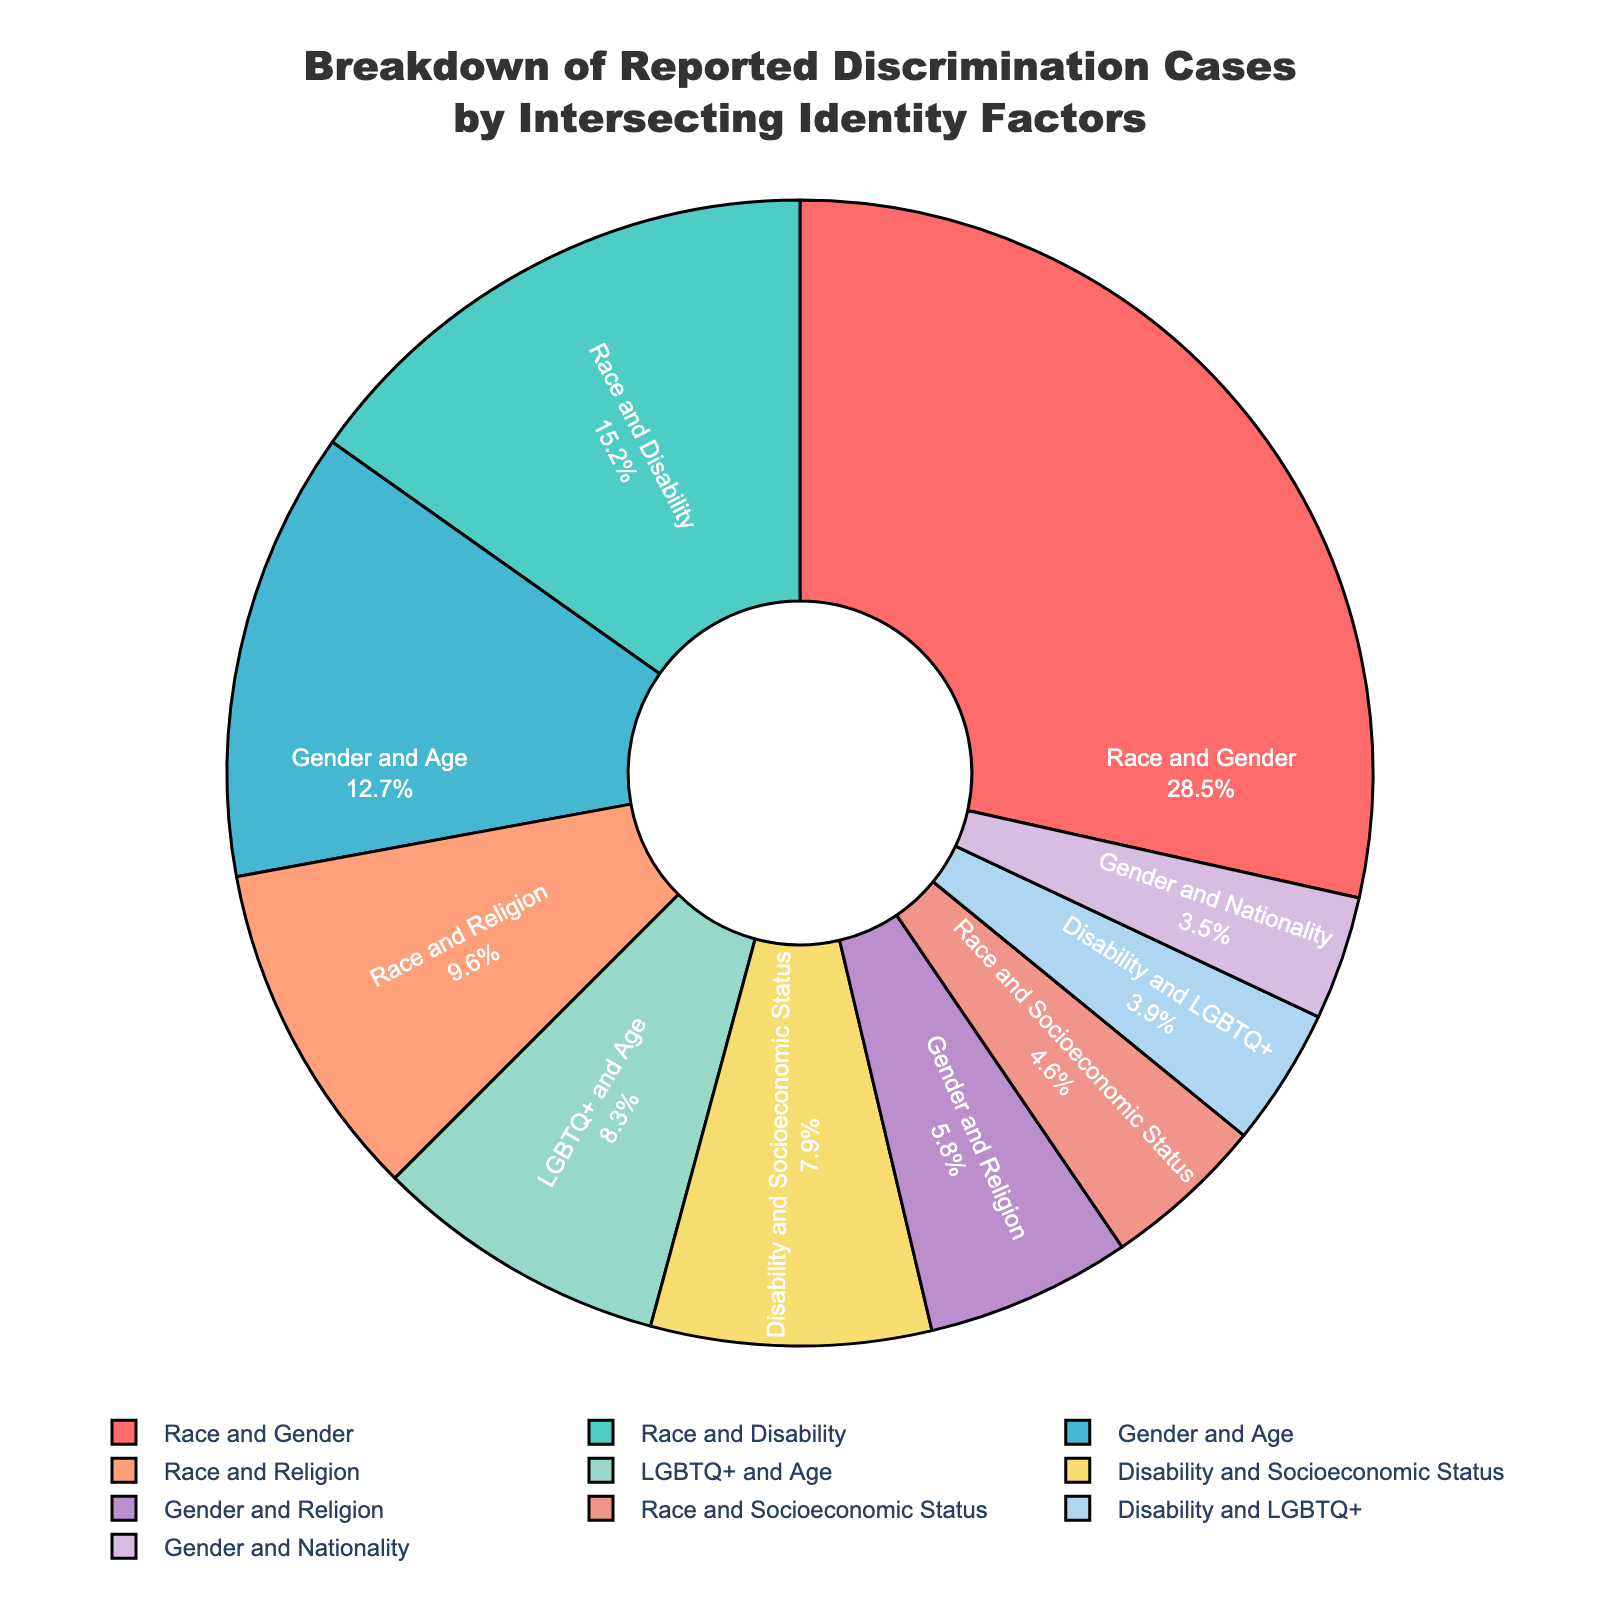What is the largest category of reported discrimination cases? The category "Race and Gender" has the largest percentage of reported discrimination cases at 28.5%.
Answer: Race and Gender What is the total percentage of discrimination cases that involve race? Adding the percentages for categories involving race: Race and Gender (28.5), Race and Disability (15.2), Race and Religion (9.6), and Race and Socioeconomic Status (4.6), the total is 28.5 + 15.2 + 9.6 + 4.6 = 57.9%.
Answer: 57.9% Which has more reported discrimination cases: Disability and LGBTQ+ or Gender and Nationality? Comparing the percentages, Disability and LGBTQ+ has 3.9% while Gender and Nationality has 3.5%. Therefore, Disability and LGBTQ+ has more cases.
Answer: Disability and LGBTQ+ How does the percentage of reported cases involving Disability and Socioeconomic Status compare to that involving Disability and LGBTQ+? The percentage for Disability and Socioeconomic Status is 7.9%, while for Disability and LGBTQ+ it is 3.9%. Hence, cases involving Disability and Socioeconomic Status are 4% higher.
Answer: 4% higher What is the combined percentage of reported discrimination cases involving Gender? Adding the percentages for categories involving gender: Race and Gender (28.5), Gender and Age (12.7), Gender and Religion (5.8), and Gender and Nationality (3.5), the total is 28.5 + 12.7 + 5.8 + 3.5 = 50.5%.
Answer: 50.5% Which categories have less than 5% of reported discrimination cases? The categories Race and Socioeconomic Status (4.6%), Disability and LGBTQ+ (3.9%), and Gender and Nationality (3.5%) each have less than 5% of reported cases.
Answer: Race and Socioeconomic Status, Disability and LGBTQ+, Gender and Nationality What is the median percentage of reported discrimination cases among all categories? The percentages are: 28.5, 15.2, 12.7, 9.6, 8.3, 7.9, 5.8, 4.6, 3.9, 3.5. Arranging them in ascending order: 3.5, 3.9, 4.6, 5.8, 7.9, 8.3, 9.6, 12.7, 15.2, 28.5. The median is the average of the 5th and 6th values: (7.9 + 8.3) / 2 = 8.1.
Answer: 8.1 What is the difference between the highest and lowest percentages of reported discrimination cases? The highest percentage is Race and Gender at 28.5%, and the lowest is Gender and Nationality at 3.5%. The difference is 28.5 - 3.5 = 25%.
Answer: 25% What color represents the category with the second highest percentage of reported discrimination cases? The second highest percentage is Race and Disability at 15.2%, represented by the color blue.
Answer: Blue How many categories have a percentage of reported discrimination cases greater than 10%? The categories are Race and Gender (28.5%), Race and Disability (15.2%), and Gender and Age (12.7%), making a total of three categories.
Answer: Three 